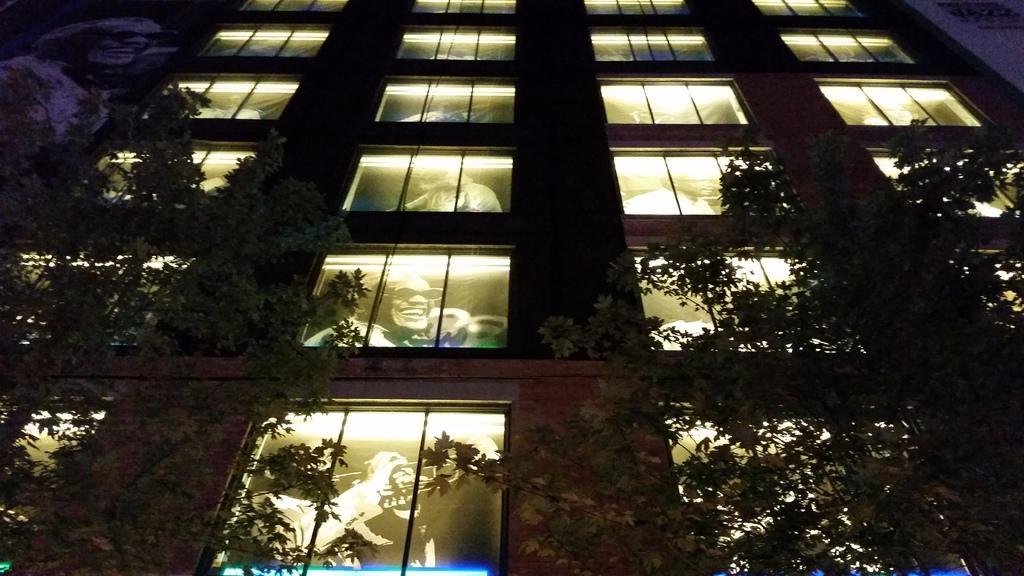How would you summarize this image in a sentence or two? In this image there is a building having few glass windows. On the windows there is paintings of few persons on it. Before the building there are few trees. 